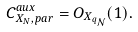Convert formula to latex. <formula><loc_0><loc_0><loc_500><loc_500>C _ { X _ { N } , p a r } ^ { a u x } = O _ { X _ { q _ { \mathcal { N } } } } ( 1 ) .</formula> 